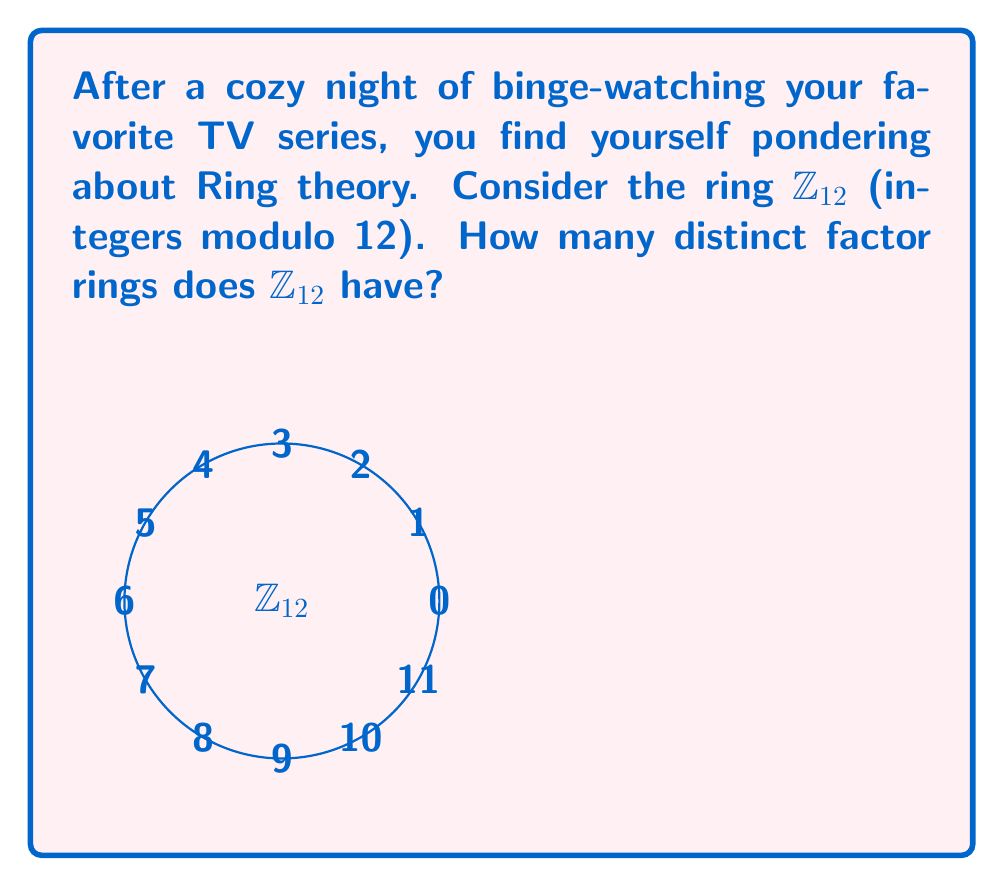Help me with this question. To find the number of distinct factor rings of $\mathbb{Z}_{12}$, we need to follow these steps:

1) First, recall that the factor rings of $\mathbb{Z}_{12}$ correspond to its ideals.

2) The ideals of $\mathbb{Z}_{12}$ are generated by the divisors of 12.

3) Let's list the divisors of 12: 1, 2, 3, 4, 6, and 12.

4) Now, let's consider each divisor:

   a) $\langle 1 \rangle = \mathbb{Z}_{12}$
   b) $\langle 2 \rangle = \{0, 2, 4, 6, 8, 10\}$
   c) $\langle 3 \rangle = \{0, 3, 6, 9\}$
   d) $\langle 4 \rangle = \{0, 4, 8\}$
   e) $\langle 6 \rangle = \{0, 6\}$
   f) $\langle 12 \rangle = \{0\}$

5) Each of these ideals corresponds to a distinct factor ring:

   a) $\mathbb{Z}_{12} / \langle 1 \rangle \cong \{0\}$
   b) $\mathbb{Z}_{12} / \langle 2 \rangle \cong \mathbb{Z}_2$
   c) $\mathbb{Z}_{12} / \langle 3 \rangle \cong \mathbb{Z}_3$
   d) $\mathbb{Z}_{12} / \langle 4 \rangle \cong \mathbb{Z}_4$
   e) $\mathbb{Z}_{12} / \langle 6 \rangle \cong \mathbb{Z}_6$
   f) $\mathbb{Z}_{12} / \langle 12 \rangle \cong \mathbb{Z}_{12}$

6) Therefore, the number of distinct factor rings is equal to the number of divisors of 12, which is 6.
Answer: 6 